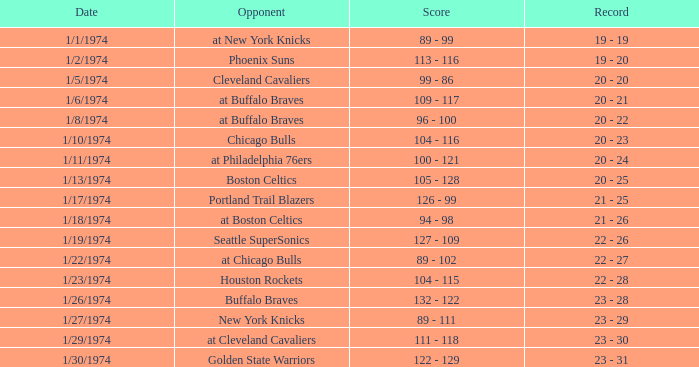What opponent played on 1/13/1974? Boston Celtics. 